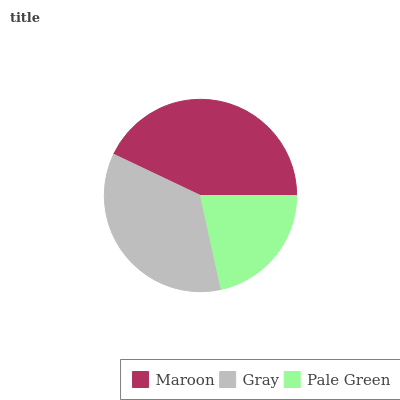Is Pale Green the minimum?
Answer yes or no. Yes. Is Maroon the maximum?
Answer yes or no. Yes. Is Gray the minimum?
Answer yes or no. No. Is Gray the maximum?
Answer yes or no. No. Is Maroon greater than Gray?
Answer yes or no. Yes. Is Gray less than Maroon?
Answer yes or no. Yes. Is Gray greater than Maroon?
Answer yes or no. No. Is Maroon less than Gray?
Answer yes or no. No. Is Gray the high median?
Answer yes or no. Yes. Is Gray the low median?
Answer yes or no. Yes. Is Pale Green the high median?
Answer yes or no. No. Is Pale Green the low median?
Answer yes or no. No. 